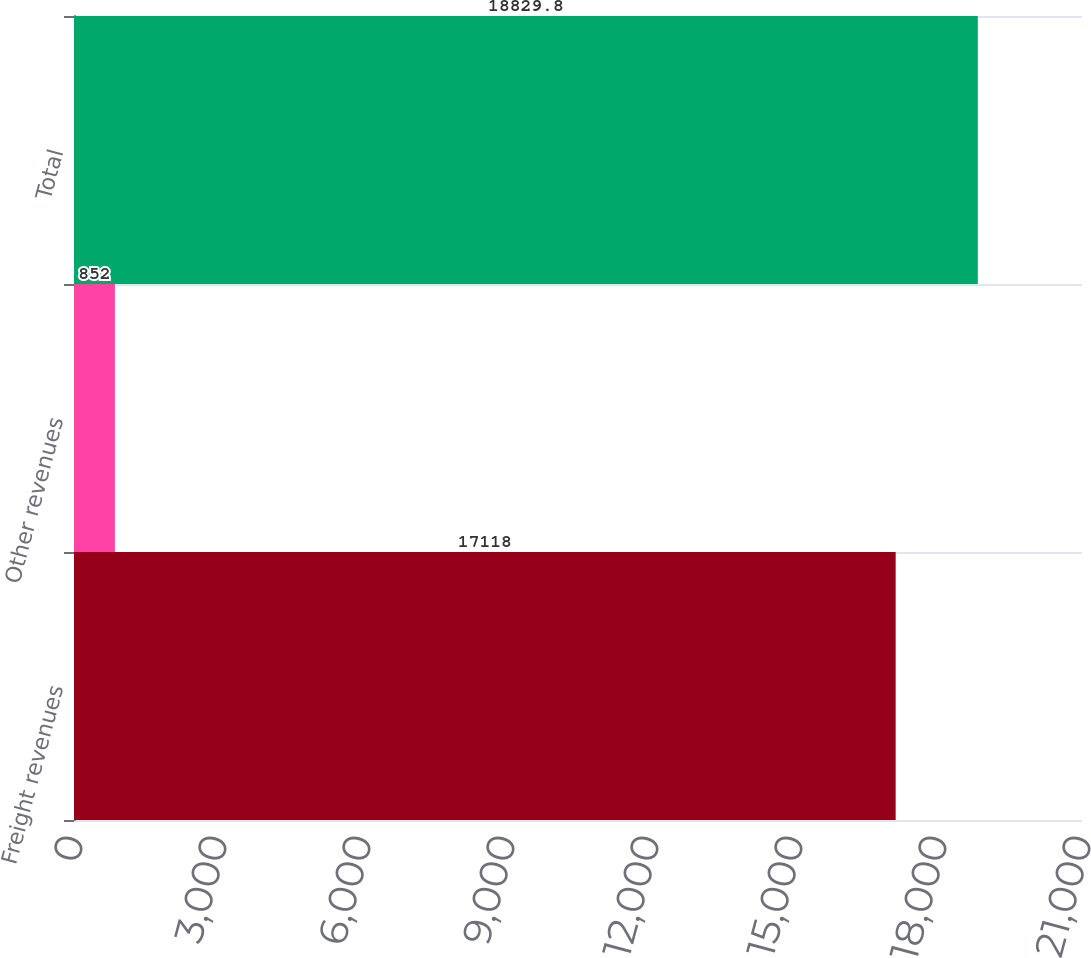<chart> <loc_0><loc_0><loc_500><loc_500><bar_chart><fcel>Freight revenues<fcel>Other revenues<fcel>Total<nl><fcel>17118<fcel>852<fcel>18829.8<nl></chart> 